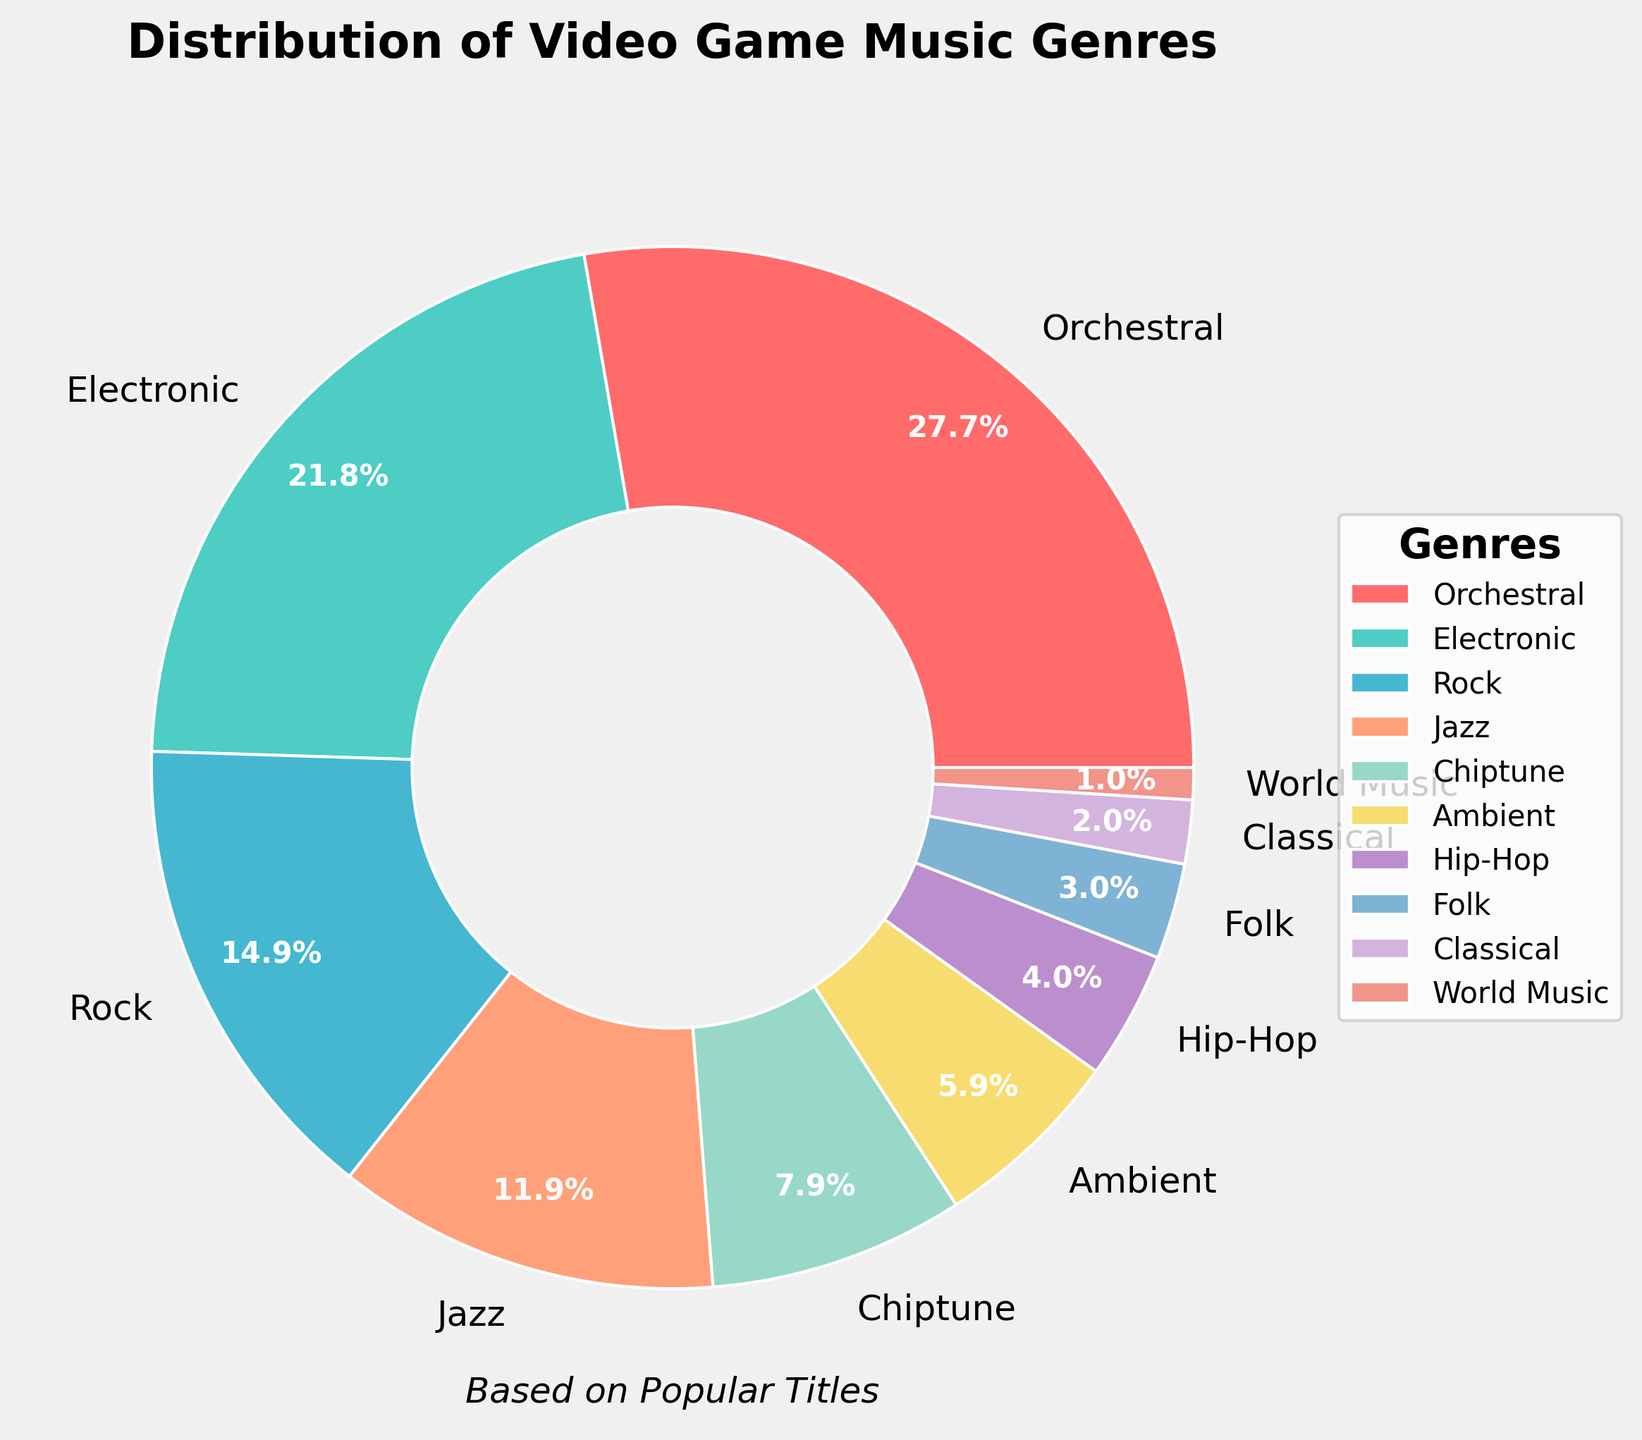what percentage of video game music genres is comprised of Electronic and Rock together? First, find the percentage of Electronic and Rock from the chart, which are 22% and 15% respectively. Then sum them up: 22% + 15% = 37%.
Answer: 37% Which genre constitutes the smallest portion of the video game music distribution? Look at the percentages for all the genres and identify the smallest one. World Music has the smallest percentage at 1%.
Answer: World Music Is the percentage of Orchestral music greater than the combined percentage of Folk and Hip-Hop? Compare the percentage of Orchestral music (28%) with the combined percentage of Folk (3%) and Hip-Hop (4%): 28% > 3% + 4% = 7%. Therefore, Orchestral is greater.
Answer: Yes How much larger is the Jazz segment compared to the Chiptune segment? Identify the percentages for Jazz and Chiptune from the chart: Jazz is 12% and Chiptune is 8%. Calculate the difference: 12% - 8% = 4%.
Answer: 4% Which segment is represented by a color closest to green? Observe the colors and choices: Electronic music is represented by a teal color, which is closest to green.
Answer: Electronic Are there more segments with a percentage greater than 10% or with a percentage less than 10%? Count the segments with percentages greater than 10%: Orchestral (28%), Electronic (22%), Rock (15%), and Jazz (12%) - total is 4 segments. Now count segments with percentages less than 10%: Chiptune (8%), Ambient (6%), Hip-Hop (4%), Folk (3%), Classical (2%), World Music (1%) - total is 6 segments. There are more segments with less than 10%.
Answer: Less than 10% Which genre is represented by the second-largest slice in the pie chart? Identify the genre with second-largest percentage: Orchestral (28%), Electronic (22%). So, Electronic is the second-largest.
Answer: Electronic If you combined the percentages of Ambient, Folk, and Classical music, would it total more than that of Rock music? Find the sum of Ambient (6%), Folk (3%), and Classical (2%): 6% + 3% + 2% = 11%. Compare it with Rock (15%): 11% < 15%, so it's less.
Answer: No How many genres have a percentage share below 5%? Identify the genres with percentages below 5%: Hip-Hop (4%), Folk (3%), Classical (2%), and World Music (1%) . There are 4 genres in total.
Answer: 4 